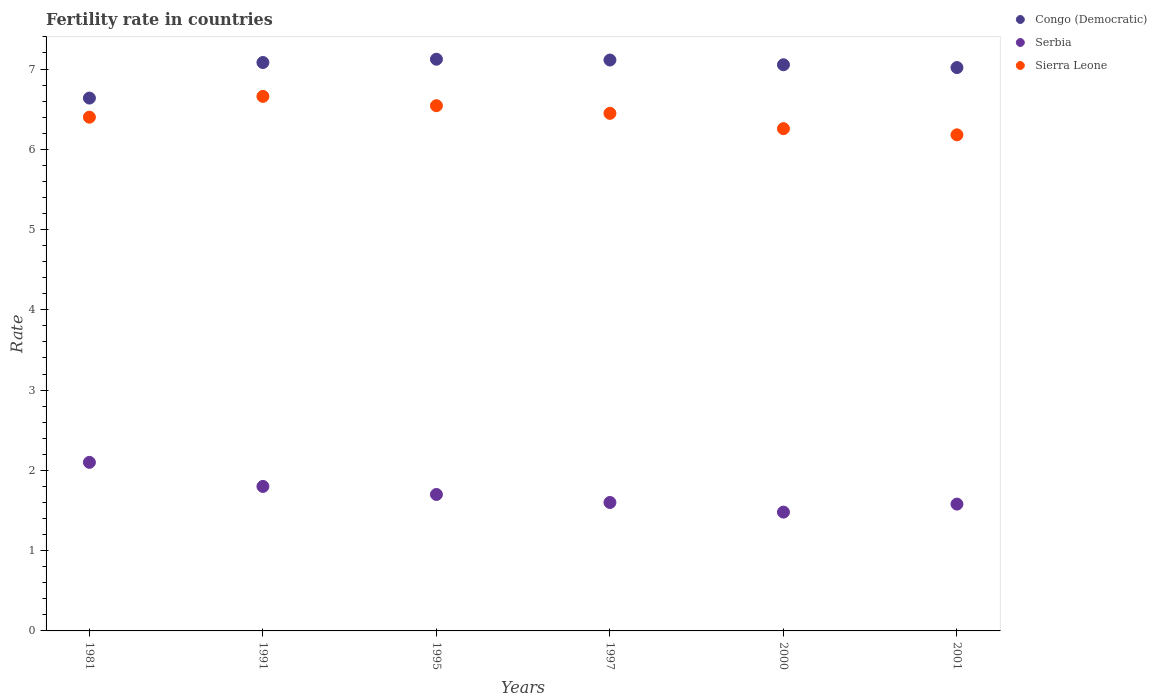How many different coloured dotlines are there?
Your answer should be compact. 3. Is the number of dotlines equal to the number of legend labels?
Your answer should be compact. Yes. What is the fertility rate in Sierra Leone in 1981?
Provide a succinct answer. 6.4. Across all years, what is the maximum fertility rate in Sierra Leone?
Your answer should be very brief. 6.66. Across all years, what is the minimum fertility rate in Sierra Leone?
Provide a short and direct response. 6.18. What is the total fertility rate in Serbia in the graph?
Provide a short and direct response. 10.26. What is the difference between the fertility rate in Serbia in 2000 and that in 2001?
Provide a short and direct response. -0.1. What is the difference between the fertility rate in Congo (Democratic) in 1981 and the fertility rate in Serbia in 1997?
Your response must be concise. 5.04. What is the average fertility rate in Sierra Leone per year?
Your response must be concise. 6.41. In the year 2000, what is the difference between the fertility rate in Serbia and fertility rate in Sierra Leone?
Make the answer very short. -4.78. In how many years, is the fertility rate in Serbia greater than 6.6?
Your answer should be compact. 0. What is the ratio of the fertility rate in Congo (Democratic) in 1981 to that in 1991?
Provide a succinct answer. 0.94. Is the fertility rate in Congo (Democratic) in 1995 less than that in 1997?
Make the answer very short. No. Is the difference between the fertility rate in Serbia in 1981 and 1997 greater than the difference between the fertility rate in Sierra Leone in 1981 and 1997?
Ensure brevity in your answer.  Yes. What is the difference between the highest and the second highest fertility rate in Serbia?
Offer a very short reply. 0.3. What is the difference between the highest and the lowest fertility rate in Serbia?
Your answer should be compact. 0.62. Is it the case that in every year, the sum of the fertility rate in Serbia and fertility rate in Sierra Leone  is greater than the fertility rate in Congo (Democratic)?
Provide a succinct answer. Yes. Is the fertility rate in Serbia strictly less than the fertility rate in Congo (Democratic) over the years?
Your answer should be very brief. Yes. How many years are there in the graph?
Your answer should be very brief. 6. What is the difference between two consecutive major ticks on the Y-axis?
Ensure brevity in your answer.  1. Are the values on the major ticks of Y-axis written in scientific E-notation?
Provide a short and direct response. No. Does the graph contain any zero values?
Provide a succinct answer. No. How many legend labels are there?
Give a very brief answer. 3. How are the legend labels stacked?
Your response must be concise. Vertical. What is the title of the graph?
Keep it short and to the point. Fertility rate in countries. Does "Chad" appear as one of the legend labels in the graph?
Offer a very short reply. No. What is the label or title of the Y-axis?
Provide a short and direct response. Rate. What is the Rate in Congo (Democratic) in 1981?
Provide a short and direct response. 6.64. What is the Rate in Congo (Democratic) in 1991?
Give a very brief answer. 7.08. What is the Rate in Serbia in 1991?
Your answer should be very brief. 1.8. What is the Rate of Sierra Leone in 1991?
Offer a very short reply. 6.66. What is the Rate of Congo (Democratic) in 1995?
Give a very brief answer. 7.12. What is the Rate in Serbia in 1995?
Offer a very short reply. 1.7. What is the Rate of Sierra Leone in 1995?
Provide a short and direct response. 6.54. What is the Rate in Congo (Democratic) in 1997?
Provide a succinct answer. 7.11. What is the Rate in Sierra Leone in 1997?
Your response must be concise. 6.45. What is the Rate in Congo (Democratic) in 2000?
Ensure brevity in your answer.  7.05. What is the Rate in Serbia in 2000?
Provide a short and direct response. 1.48. What is the Rate of Sierra Leone in 2000?
Give a very brief answer. 6.26. What is the Rate of Congo (Democratic) in 2001?
Keep it short and to the point. 7.02. What is the Rate of Serbia in 2001?
Provide a short and direct response. 1.58. What is the Rate in Sierra Leone in 2001?
Your response must be concise. 6.18. Across all years, what is the maximum Rate in Congo (Democratic)?
Keep it short and to the point. 7.12. Across all years, what is the maximum Rate of Serbia?
Offer a terse response. 2.1. Across all years, what is the maximum Rate of Sierra Leone?
Provide a succinct answer. 6.66. Across all years, what is the minimum Rate of Congo (Democratic)?
Give a very brief answer. 6.64. Across all years, what is the minimum Rate of Serbia?
Ensure brevity in your answer.  1.48. Across all years, what is the minimum Rate of Sierra Leone?
Give a very brief answer. 6.18. What is the total Rate in Congo (Democratic) in the graph?
Make the answer very short. 42.02. What is the total Rate of Serbia in the graph?
Make the answer very short. 10.26. What is the total Rate of Sierra Leone in the graph?
Make the answer very short. 38.49. What is the difference between the Rate of Congo (Democratic) in 1981 and that in 1991?
Offer a terse response. -0.44. What is the difference between the Rate in Serbia in 1981 and that in 1991?
Make the answer very short. 0.3. What is the difference between the Rate of Sierra Leone in 1981 and that in 1991?
Offer a very short reply. -0.26. What is the difference between the Rate of Congo (Democratic) in 1981 and that in 1995?
Provide a succinct answer. -0.48. What is the difference between the Rate of Serbia in 1981 and that in 1995?
Make the answer very short. 0.4. What is the difference between the Rate of Sierra Leone in 1981 and that in 1995?
Provide a succinct answer. -0.14. What is the difference between the Rate of Congo (Democratic) in 1981 and that in 1997?
Give a very brief answer. -0.47. What is the difference between the Rate in Serbia in 1981 and that in 1997?
Your answer should be compact. 0.5. What is the difference between the Rate in Sierra Leone in 1981 and that in 1997?
Keep it short and to the point. -0.05. What is the difference between the Rate of Congo (Democratic) in 1981 and that in 2000?
Ensure brevity in your answer.  -0.41. What is the difference between the Rate of Serbia in 1981 and that in 2000?
Ensure brevity in your answer.  0.62. What is the difference between the Rate of Sierra Leone in 1981 and that in 2000?
Ensure brevity in your answer.  0.14. What is the difference between the Rate in Congo (Democratic) in 1981 and that in 2001?
Give a very brief answer. -0.38. What is the difference between the Rate of Serbia in 1981 and that in 2001?
Provide a succinct answer. 0.52. What is the difference between the Rate of Sierra Leone in 1981 and that in 2001?
Your response must be concise. 0.22. What is the difference between the Rate of Congo (Democratic) in 1991 and that in 1995?
Provide a short and direct response. -0.04. What is the difference between the Rate of Sierra Leone in 1991 and that in 1995?
Provide a short and direct response. 0.12. What is the difference between the Rate in Congo (Democratic) in 1991 and that in 1997?
Offer a terse response. -0.03. What is the difference between the Rate of Serbia in 1991 and that in 1997?
Give a very brief answer. 0.2. What is the difference between the Rate of Sierra Leone in 1991 and that in 1997?
Provide a short and direct response. 0.21. What is the difference between the Rate in Congo (Democratic) in 1991 and that in 2000?
Keep it short and to the point. 0.03. What is the difference between the Rate of Serbia in 1991 and that in 2000?
Offer a very short reply. 0.32. What is the difference between the Rate in Sierra Leone in 1991 and that in 2000?
Give a very brief answer. 0.4. What is the difference between the Rate of Congo (Democratic) in 1991 and that in 2001?
Offer a terse response. 0.06. What is the difference between the Rate of Serbia in 1991 and that in 2001?
Ensure brevity in your answer.  0.22. What is the difference between the Rate of Sierra Leone in 1991 and that in 2001?
Your answer should be very brief. 0.48. What is the difference between the Rate in Sierra Leone in 1995 and that in 1997?
Your answer should be compact. 0.1. What is the difference between the Rate of Congo (Democratic) in 1995 and that in 2000?
Ensure brevity in your answer.  0.07. What is the difference between the Rate in Serbia in 1995 and that in 2000?
Ensure brevity in your answer.  0.22. What is the difference between the Rate of Sierra Leone in 1995 and that in 2000?
Provide a short and direct response. 0.29. What is the difference between the Rate of Congo (Democratic) in 1995 and that in 2001?
Make the answer very short. 0.1. What is the difference between the Rate of Serbia in 1995 and that in 2001?
Your answer should be compact. 0.12. What is the difference between the Rate in Sierra Leone in 1995 and that in 2001?
Your answer should be compact. 0.36. What is the difference between the Rate of Congo (Democratic) in 1997 and that in 2000?
Provide a succinct answer. 0.06. What is the difference between the Rate in Serbia in 1997 and that in 2000?
Ensure brevity in your answer.  0.12. What is the difference between the Rate of Sierra Leone in 1997 and that in 2000?
Offer a very short reply. 0.19. What is the difference between the Rate of Congo (Democratic) in 1997 and that in 2001?
Your answer should be very brief. 0.09. What is the difference between the Rate in Sierra Leone in 1997 and that in 2001?
Ensure brevity in your answer.  0.27. What is the difference between the Rate of Congo (Democratic) in 2000 and that in 2001?
Offer a very short reply. 0.04. What is the difference between the Rate of Sierra Leone in 2000 and that in 2001?
Ensure brevity in your answer.  0.08. What is the difference between the Rate of Congo (Democratic) in 1981 and the Rate of Serbia in 1991?
Your response must be concise. 4.84. What is the difference between the Rate of Congo (Democratic) in 1981 and the Rate of Sierra Leone in 1991?
Keep it short and to the point. -0.02. What is the difference between the Rate in Serbia in 1981 and the Rate in Sierra Leone in 1991?
Your response must be concise. -4.56. What is the difference between the Rate of Congo (Democratic) in 1981 and the Rate of Serbia in 1995?
Your answer should be very brief. 4.94. What is the difference between the Rate in Congo (Democratic) in 1981 and the Rate in Sierra Leone in 1995?
Give a very brief answer. 0.1. What is the difference between the Rate of Serbia in 1981 and the Rate of Sierra Leone in 1995?
Offer a very short reply. -4.44. What is the difference between the Rate in Congo (Democratic) in 1981 and the Rate in Serbia in 1997?
Make the answer very short. 5.04. What is the difference between the Rate of Congo (Democratic) in 1981 and the Rate of Sierra Leone in 1997?
Your answer should be very brief. 0.19. What is the difference between the Rate of Serbia in 1981 and the Rate of Sierra Leone in 1997?
Your answer should be very brief. -4.35. What is the difference between the Rate in Congo (Democratic) in 1981 and the Rate in Serbia in 2000?
Offer a very short reply. 5.16. What is the difference between the Rate of Congo (Democratic) in 1981 and the Rate of Sierra Leone in 2000?
Offer a terse response. 0.38. What is the difference between the Rate in Serbia in 1981 and the Rate in Sierra Leone in 2000?
Offer a very short reply. -4.16. What is the difference between the Rate of Congo (Democratic) in 1981 and the Rate of Serbia in 2001?
Provide a short and direct response. 5.06. What is the difference between the Rate in Congo (Democratic) in 1981 and the Rate in Sierra Leone in 2001?
Offer a very short reply. 0.46. What is the difference between the Rate in Serbia in 1981 and the Rate in Sierra Leone in 2001?
Keep it short and to the point. -4.08. What is the difference between the Rate of Congo (Democratic) in 1991 and the Rate of Serbia in 1995?
Provide a succinct answer. 5.38. What is the difference between the Rate in Congo (Democratic) in 1991 and the Rate in Sierra Leone in 1995?
Offer a very short reply. 0.54. What is the difference between the Rate of Serbia in 1991 and the Rate of Sierra Leone in 1995?
Your response must be concise. -4.74. What is the difference between the Rate of Congo (Democratic) in 1991 and the Rate of Serbia in 1997?
Your response must be concise. 5.48. What is the difference between the Rate in Congo (Democratic) in 1991 and the Rate in Sierra Leone in 1997?
Make the answer very short. 0.63. What is the difference between the Rate in Serbia in 1991 and the Rate in Sierra Leone in 1997?
Provide a short and direct response. -4.65. What is the difference between the Rate in Congo (Democratic) in 1991 and the Rate in Serbia in 2000?
Keep it short and to the point. 5.6. What is the difference between the Rate in Congo (Democratic) in 1991 and the Rate in Sierra Leone in 2000?
Give a very brief answer. 0.82. What is the difference between the Rate of Serbia in 1991 and the Rate of Sierra Leone in 2000?
Ensure brevity in your answer.  -4.46. What is the difference between the Rate in Congo (Democratic) in 1991 and the Rate in Serbia in 2001?
Offer a terse response. 5.5. What is the difference between the Rate of Congo (Democratic) in 1991 and the Rate of Sierra Leone in 2001?
Provide a succinct answer. 0.9. What is the difference between the Rate in Serbia in 1991 and the Rate in Sierra Leone in 2001?
Offer a very short reply. -4.38. What is the difference between the Rate in Congo (Democratic) in 1995 and the Rate in Serbia in 1997?
Provide a succinct answer. 5.52. What is the difference between the Rate of Congo (Democratic) in 1995 and the Rate of Sierra Leone in 1997?
Give a very brief answer. 0.67. What is the difference between the Rate in Serbia in 1995 and the Rate in Sierra Leone in 1997?
Ensure brevity in your answer.  -4.75. What is the difference between the Rate of Congo (Democratic) in 1995 and the Rate of Serbia in 2000?
Offer a very short reply. 5.64. What is the difference between the Rate of Congo (Democratic) in 1995 and the Rate of Sierra Leone in 2000?
Keep it short and to the point. 0.86. What is the difference between the Rate of Serbia in 1995 and the Rate of Sierra Leone in 2000?
Make the answer very short. -4.56. What is the difference between the Rate of Congo (Democratic) in 1995 and the Rate of Serbia in 2001?
Your response must be concise. 5.54. What is the difference between the Rate of Congo (Democratic) in 1995 and the Rate of Sierra Leone in 2001?
Your answer should be compact. 0.94. What is the difference between the Rate in Serbia in 1995 and the Rate in Sierra Leone in 2001?
Ensure brevity in your answer.  -4.48. What is the difference between the Rate of Congo (Democratic) in 1997 and the Rate of Serbia in 2000?
Your response must be concise. 5.63. What is the difference between the Rate of Congo (Democratic) in 1997 and the Rate of Sierra Leone in 2000?
Ensure brevity in your answer.  0.85. What is the difference between the Rate of Serbia in 1997 and the Rate of Sierra Leone in 2000?
Ensure brevity in your answer.  -4.66. What is the difference between the Rate of Congo (Democratic) in 1997 and the Rate of Serbia in 2001?
Keep it short and to the point. 5.53. What is the difference between the Rate of Congo (Democratic) in 1997 and the Rate of Sierra Leone in 2001?
Provide a short and direct response. 0.93. What is the difference between the Rate of Serbia in 1997 and the Rate of Sierra Leone in 2001?
Ensure brevity in your answer.  -4.58. What is the difference between the Rate of Congo (Democratic) in 2000 and the Rate of Serbia in 2001?
Give a very brief answer. 5.47. What is the difference between the Rate in Congo (Democratic) in 2000 and the Rate in Sierra Leone in 2001?
Ensure brevity in your answer.  0.87. What is the average Rate in Congo (Democratic) per year?
Offer a very short reply. 7. What is the average Rate of Serbia per year?
Offer a very short reply. 1.71. What is the average Rate of Sierra Leone per year?
Offer a very short reply. 6.41. In the year 1981, what is the difference between the Rate in Congo (Democratic) and Rate in Serbia?
Offer a terse response. 4.54. In the year 1981, what is the difference between the Rate of Congo (Democratic) and Rate of Sierra Leone?
Offer a terse response. 0.24. In the year 1991, what is the difference between the Rate in Congo (Democratic) and Rate in Serbia?
Provide a succinct answer. 5.28. In the year 1991, what is the difference between the Rate of Congo (Democratic) and Rate of Sierra Leone?
Your answer should be very brief. 0.42. In the year 1991, what is the difference between the Rate of Serbia and Rate of Sierra Leone?
Offer a terse response. -4.86. In the year 1995, what is the difference between the Rate of Congo (Democratic) and Rate of Serbia?
Offer a very short reply. 5.42. In the year 1995, what is the difference between the Rate in Congo (Democratic) and Rate in Sierra Leone?
Offer a terse response. 0.58. In the year 1995, what is the difference between the Rate in Serbia and Rate in Sierra Leone?
Provide a short and direct response. -4.84. In the year 1997, what is the difference between the Rate in Congo (Democratic) and Rate in Serbia?
Keep it short and to the point. 5.51. In the year 1997, what is the difference between the Rate of Congo (Democratic) and Rate of Sierra Leone?
Provide a short and direct response. 0.66. In the year 1997, what is the difference between the Rate in Serbia and Rate in Sierra Leone?
Make the answer very short. -4.85. In the year 2000, what is the difference between the Rate of Congo (Democratic) and Rate of Serbia?
Ensure brevity in your answer.  5.57. In the year 2000, what is the difference between the Rate in Congo (Democratic) and Rate in Sierra Leone?
Make the answer very short. 0.8. In the year 2000, what is the difference between the Rate in Serbia and Rate in Sierra Leone?
Provide a succinct answer. -4.78. In the year 2001, what is the difference between the Rate of Congo (Democratic) and Rate of Serbia?
Provide a short and direct response. 5.44. In the year 2001, what is the difference between the Rate of Congo (Democratic) and Rate of Sierra Leone?
Your answer should be very brief. 0.84. In the year 2001, what is the difference between the Rate in Serbia and Rate in Sierra Leone?
Your answer should be compact. -4.6. What is the ratio of the Rate of Congo (Democratic) in 1981 to that in 1991?
Offer a terse response. 0.94. What is the ratio of the Rate of Sierra Leone in 1981 to that in 1991?
Your response must be concise. 0.96. What is the ratio of the Rate in Congo (Democratic) in 1981 to that in 1995?
Keep it short and to the point. 0.93. What is the ratio of the Rate of Serbia in 1981 to that in 1995?
Your answer should be very brief. 1.24. What is the ratio of the Rate in Sierra Leone in 1981 to that in 1995?
Your response must be concise. 0.98. What is the ratio of the Rate of Congo (Democratic) in 1981 to that in 1997?
Your answer should be very brief. 0.93. What is the ratio of the Rate in Serbia in 1981 to that in 1997?
Ensure brevity in your answer.  1.31. What is the ratio of the Rate of Sierra Leone in 1981 to that in 1997?
Provide a succinct answer. 0.99. What is the ratio of the Rate in Congo (Democratic) in 1981 to that in 2000?
Provide a short and direct response. 0.94. What is the ratio of the Rate in Serbia in 1981 to that in 2000?
Your answer should be very brief. 1.42. What is the ratio of the Rate of Sierra Leone in 1981 to that in 2000?
Give a very brief answer. 1.02. What is the ratio of the Rate of Congo (Democratic) in 1981 to that in 2001?
Provide a succinct answer. 0.95. What is the ratio of the Rate of Serbia in 1981 to that in 2001?
Offer a very short reply. 1.33. What is the ratio of the Rate in Sierra Leone in 1981 to that in 2001?
Provide a succinct answer. 1.04. What is the ratio of the Rate of Congo (Democratic) in 1991 to that in 1995?
Offer a very short reply. 0.99. What is the ratio of the Rate in Serbia in 1991 to that in 1995?
Provide a succinct answer. 1.06. What is the ratio of the Rate of Sierra Leone in 1991 to that in 1995?
Keep it short and to the point. 1.02. What is the ratio of the Rate in Serbia in 1991 to that in 1997?
Offer a terse response. 1.12. What is the ratio of the Rate in Sierra Leone in 1991 to that in 1997?
Make the answer very short. 1.03. What is the ratio of the Rate in Serbia in 1991 to that in 2000?
Provide a short and direct response. 1.22. What is the ratio of the Rate in Sierra Leone in 1991 to that in 2000?
Offer a very short reply. 1.06. What is the ratio of the Rate of Serbia in 1991 to that in 2001?
Give a very brief answer. 1.14. What is the ratio of the Rate in Sierra Leone in 1991 to that in 2001?
Keep it short and to the point. 1.08. What is the ratio of the Rate of Congo (Democratic) in 1995 to that in 1997?
Give a very brief answer. 1. What is the ratio of the Rate in Sierra Leone in 1995 to that in 1997?
Your response must be concise. 1.01. What is the ratio of the Rate in Congo (Democratic) in 1995 to that in 2000?
Offer a very short reply. 1.01. What is the ratio of the Rate in Serbia in 1995 to that in 2000?
Offer a very short reply. 1.15. What is the ratio of the Rate of Sierra Leone in 1995 to that in 2000?
Your response must be concise. 1.05. What is the ratio of the Rate of Congo (Democratic) in 1995 to that in 2001?
Keep it short and to the point. 1.01. What is the ratio of the Rate of Serbia in 1995 to that in 2001?
Provide a short and direct response. 1.08. What is the ratio of the Rate of Sierra Leone in 1995 to that in 2001?
Offer a terse response. 1.06. What is the ratio of the Rate of Congo (Democratic) in 1997 to that in 2000?
Ensure brevity in your answer.  1.01. What is the ratio of the Rate of Serbia in 1997 to that in 2000?
Offer a very short reply. 1.08. What is the ratio of the Rate of Sierra Leone in 1997 to that in 2000?
Give a very brief answer. 1.03. What is the ratio of the Rate of Congo (Democratic) in 1997 to that in 2001?
Give a very brief answer. 1.01. What is the ratio of the Rate of Serbia in 1997 to that in 2001?
Make the answer very short. 1.01. What is the ratio of the Rate of Sierra Leone in 1997 to that in 2001?
Provide a short and direct response. 1.04. What is the ratio of the Rate in Serbia in 2000 to that in 2001?
Provide a succinct answer. 0.94. What is the ratio of the Rate in Sierra Leone in 2000 to that in 2001?
Provide a succinct answer. 1.01. What is the difference between the highest and the second highest Rate of Congo (Democratic)?
Your response must be concise. 0.01. What is the difference between the highest and the second highest Rate in Sierra Leone?
Your answer should be very brief. 0.12. What is the difference between the highest and the lowest Rate of Congo (Democratic)?
Provide a succinct answer. 0.48. What is the difference between the highest and the lowest Rate of Serbia?
Your response must be concise. 0.62. What is the difference between the highest and the lowest Rate in Sierra Leone?
Your answer should be compact. 0.48. 